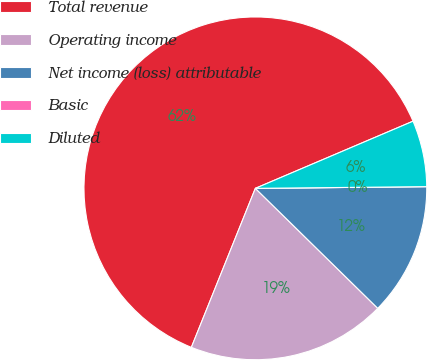Convert chart to OTSL. <chart><loc_0><loc_0><loc_500><loc_500><pie_chart><fcel>Total revenue<fcel>Operating income<fcel>Net income (loss) attributable<fcel>Basic<fcel>Diluted<nl><fcel>62.5%<fcel>18.75%<fcel>12.5%<fcel>0.0%<fcel>6.25%<nl></chart> 